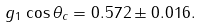Convert formula to latex. <formula><loc_0><loc_0><loc_500><loc_500>g _ { 1 } \cos \theta _ { c } = 0 . 5 7 2 \pm 0 . 0 1 6 .</formula> 